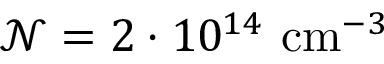Convert formula to latex. <formula><loc_0><loc_0><loc_500><loc_500>\mathcal { N } = 2 \cdot 1 0 ^ { 1 4 } c m ^ { - 3 }</formula> 